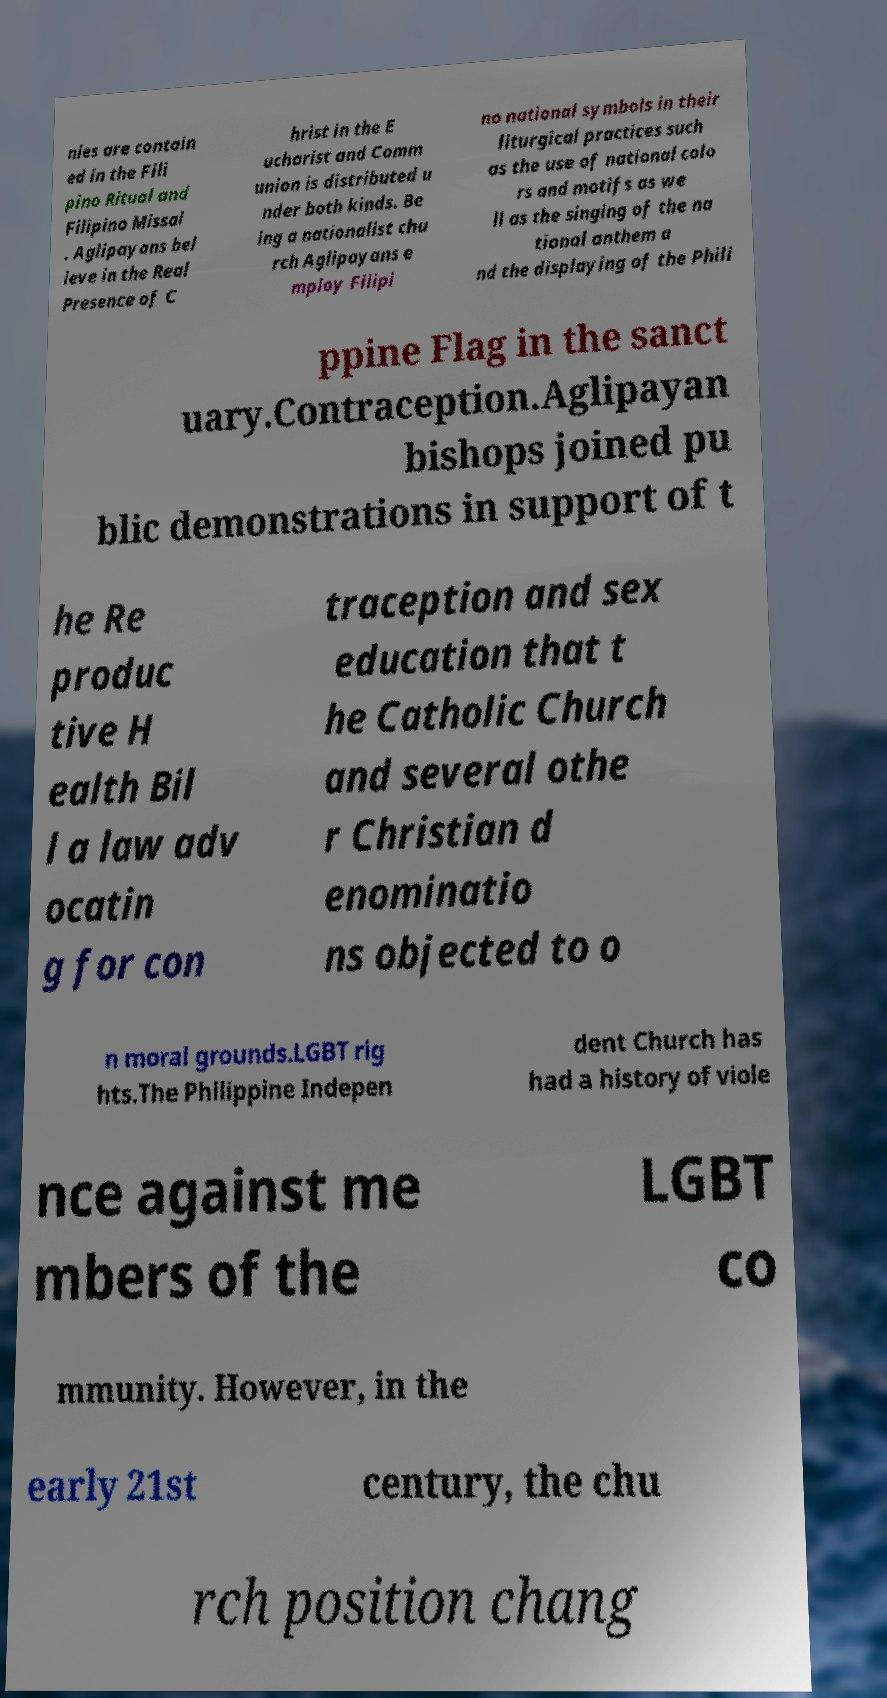I need the written content from this picture converted into text. Can you do that? nies are contain ed in the Fili pino Ritual and Filipino Missal . Aglipayans bel ieve in the Real Presence of C hrist in the E ucharist and Comm union is distributed u nder both kinds. Be ing a nationalist chu rch Aglipayans e mploy Filipi no national symbols in their liturgical practices such as the use of national colo rs and motifs as we ll as the singing of the na tional anthem a nd the displaying of the Phili ppine Flag in the sanct uary.Contraception.Aglipayan bishops joined pu blic demonstrations in support of t he Re produc tive H ealth Bil l a law adv ocatin g for con traception and sex education that t he Catholic Church and several othe r Christian d enominatio ns objected to o n moral grounds.LGBT rig hts.The Philippine Indepen dent Church has had a history of viole nce against me mbers of the LGBT co mmunity. However, in the early 21st century, the chu rch position chang 